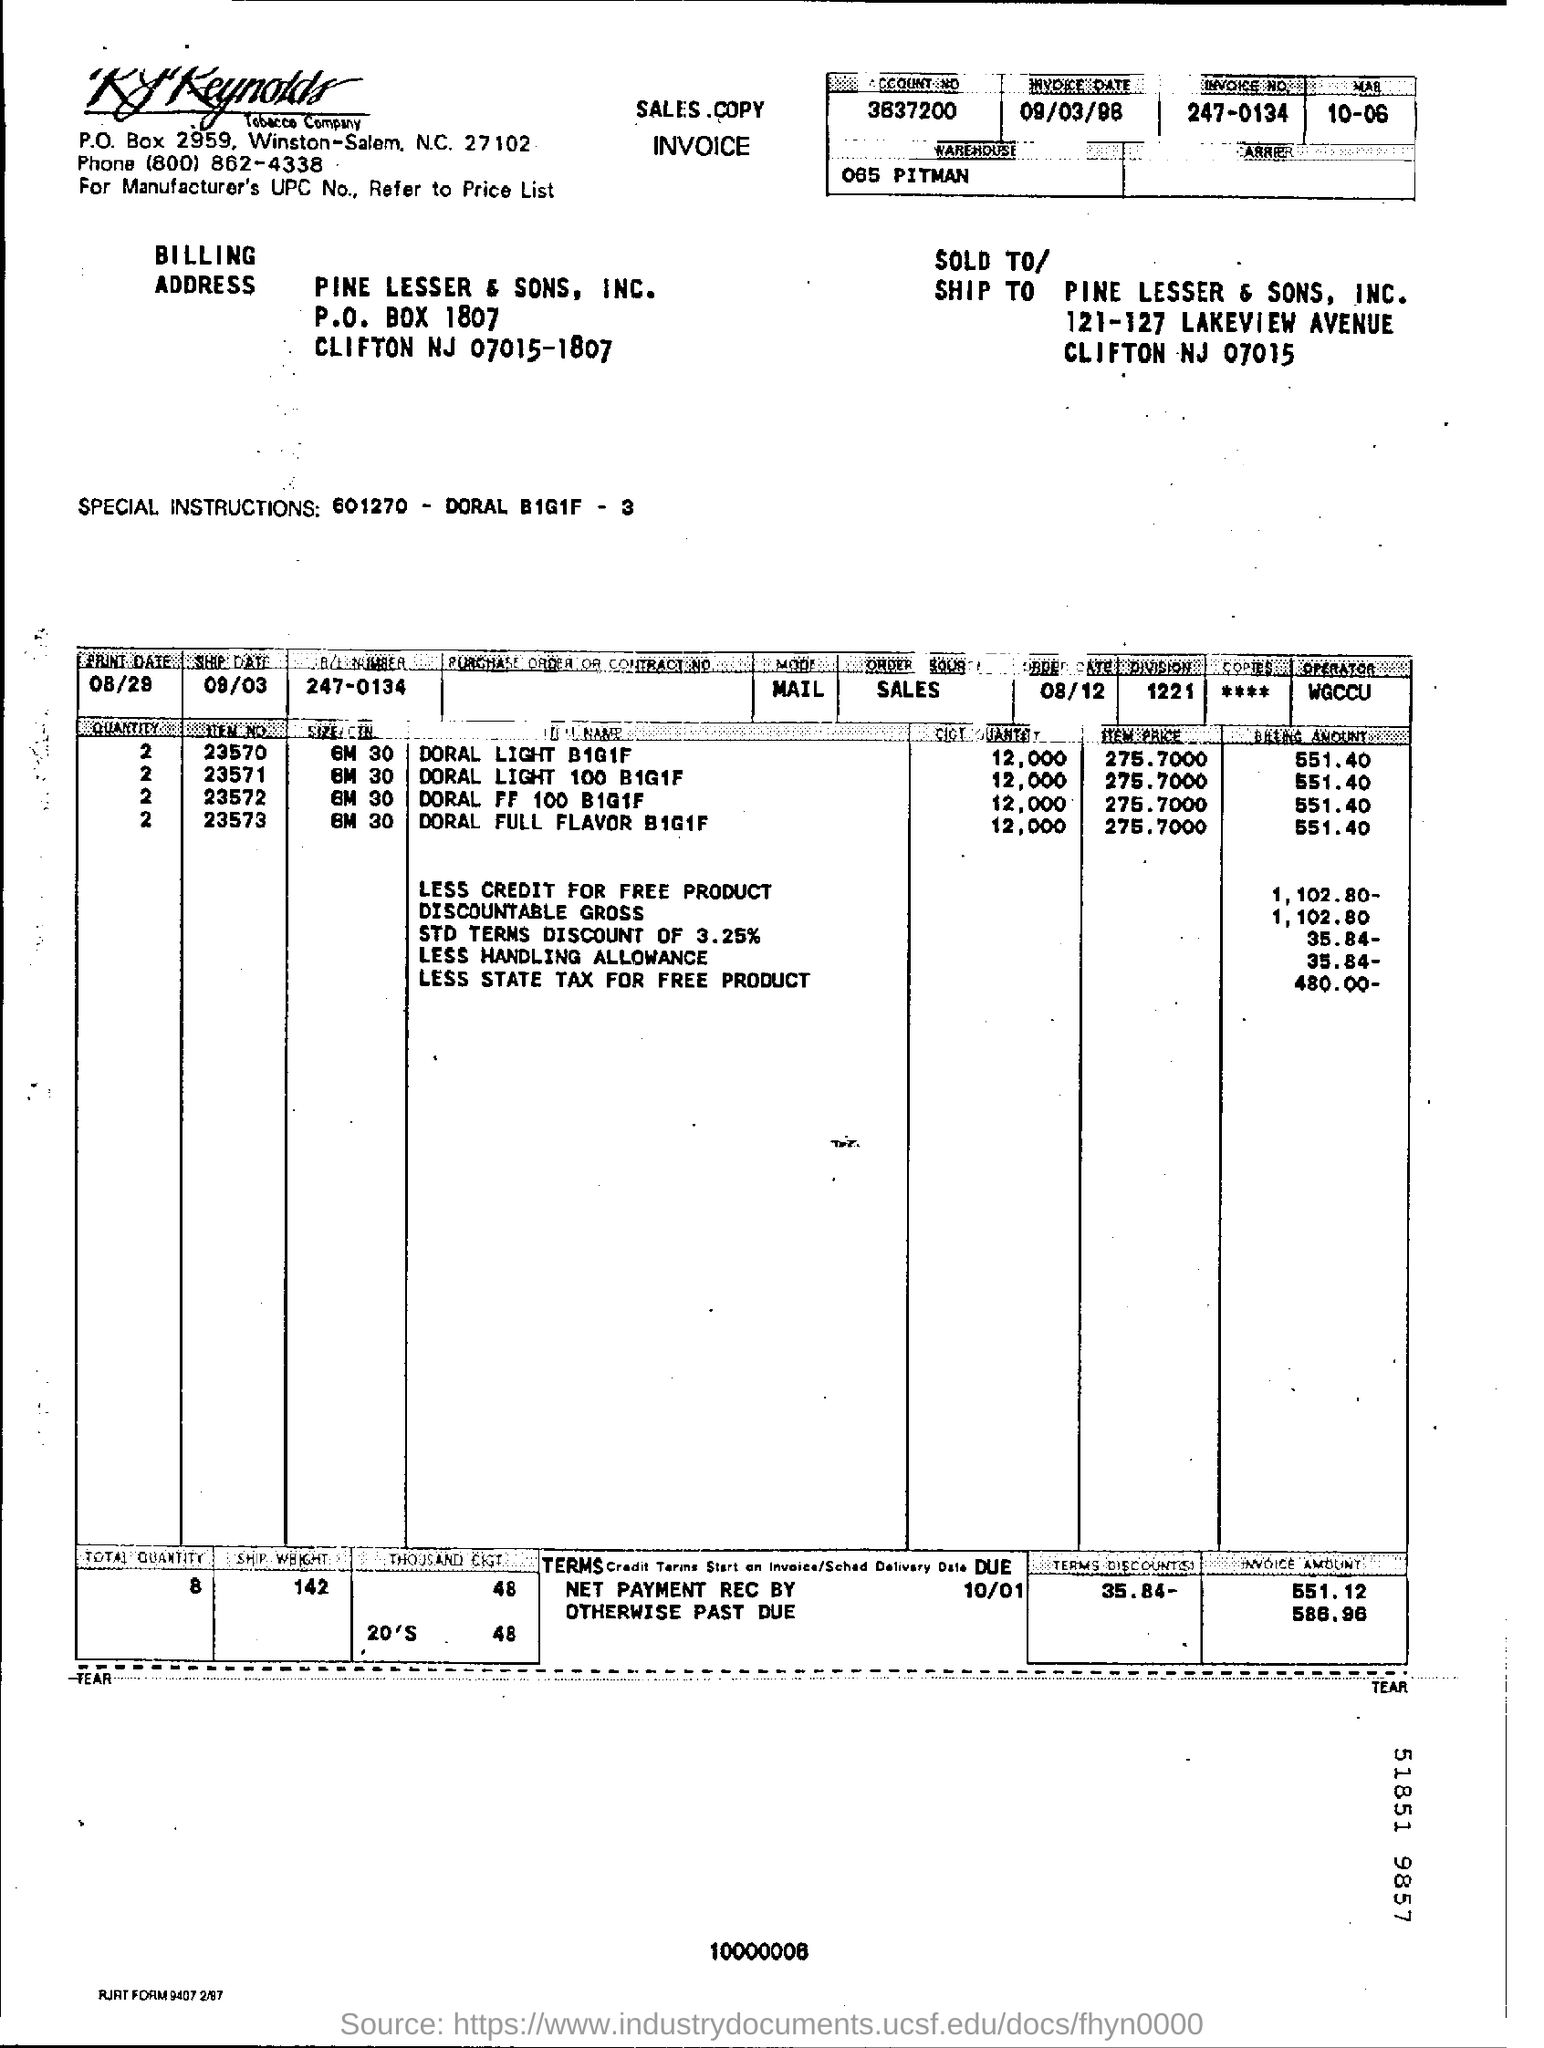What is the account number on the sales copy invoice?
Provide a short and direct response. 3637200. What is the invoice number?
Your answer should be very brief. 247-0134. What is the item price of Doral Light B1G1F?
Offer a terse response. 275.7000. 